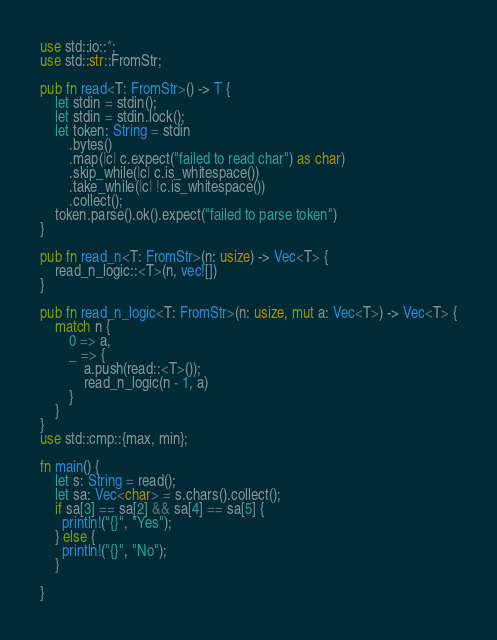<code> <loc_0><loc_0><loc_500><loc_500><_Rust_>use std::io::*;
use std::str::FromStr;

pub fn read<T: FromStr>() -> T {
    let stdin = stdin();
    let stdin = stdin.lock();
    let token: String = stdin
        .bytes()
        .map(|c| c.expect("failed to read char") as char)
        .skip_while(|c| c.is_whitespace())
        .take_while(|c| !c.is_whitespace())
        .collect();
    token.parse().ok().expect("failed to parse token")
}

pub fn read_n<T: FromStr>(n: usize) -> Vec<T> {
    read_n_logic::<T>(n, vec![])
}

pub fn read_n_logic<T: FromStr>(n: usize, mut a: Vec<T>) -> Vec<T> {
    match n {
        0 => a,
        _ => {
            a.push(read::<T>());
            read_n_logic(n - 1, a)
        }
    }
}
use std::cmp::{max, min};

fn main() {
    let s: String = read();
    let sa: Vec<char> = s.chars().collect();
    if sa[3] == sa[2] && sa[4] == sa[5] {
      println!("{}", "Yes");
    } else {
      println!("{}", "No");
    }

}
</code> 